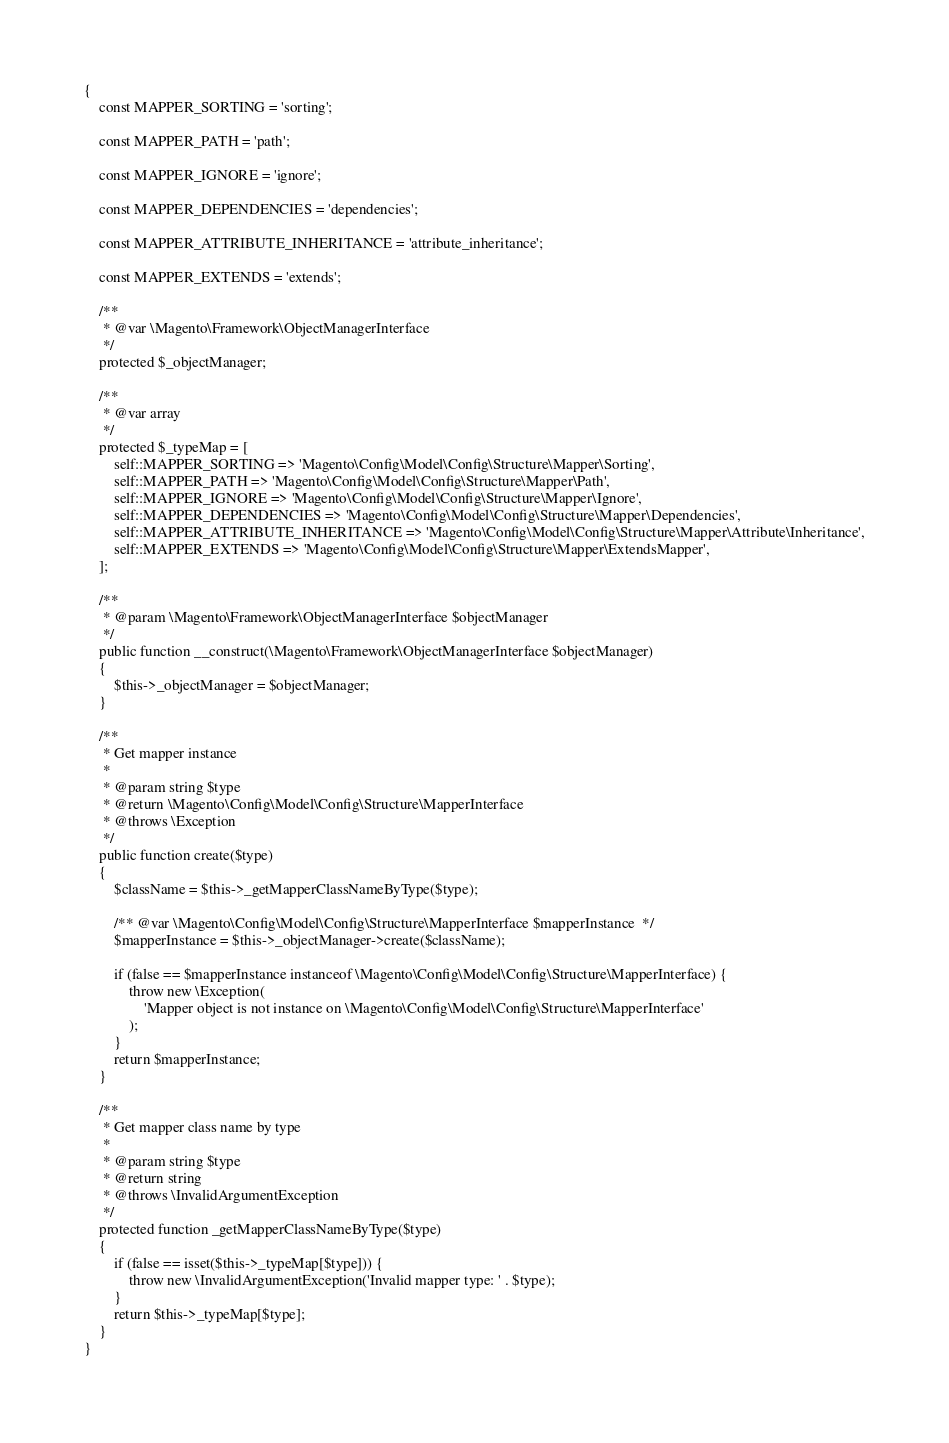Convert code to text. <code><loc_0><loc_0><loc_500><loc_500><_PHP_>{
    const MAPPER_SORTING = 'sorting';

    const MAPPER_PATH = 'path';

    const MAPPER_IGNORE = 'ignore';

    const MAPPER_DEPENDENCIES = 'dependencies';

    const MAPPER_ATTRIBUTE_INHERITANCE = 'attribute_inheritance';

    const MAPPER_EXTENDS = 'extends';

    /**
     * @var \Magento\Framework\ObjectManagerInterface
     */
    protected $_objectManager;

    /**
     * @var array
     */
    protected $_typeMap = [
        self::MAPPER_SORTING => 'Magento\Config\Model\Config\Structure\Mapper\Sorting',
        self::MAPPER_PATH => 'Magento\Config\Model\Config\Structure\Mapper\Path',
        self::MAPPER_IGNORE => 'Magento\Config\Model\Config\Structure\Mapper\Ignore',
        self::MAPPER_DEPENDENCIES => 'Magento\Config\Model\Config\Structure\Mapper\Dependencies',
        self::MAPPER_ATTRIBUTE_INHERITANCE => 'Magento\Config\Model\Config\Structure\Mapper\Attribute\Inheritance',
        self::MAPPER_EXTENDS => 'Magento\Config\Model\Config\Structure\Mapper\ExtendsMapper',
    ];

    /**
     * @param \Magento\Framework\ObjectManagerInterface $objectManager
     */
    public function __construct(\Magento\Framework\ObjectManagerInterface $objectManager)
    {
        $this->_objectManager = $objectManager;
    }

    /**
     * Get mapper instance
     *
     * @param string $type
     * @return \Magento\Config\Model\Config\Structure\MapperInterface
     * @throws \Exception
     */
    public function create($type)
    {
        $className = $this->_getMapperClassNameByType($type);

        /** @var \Magento\Config\Model\Config\Structure\MapperInterface $mapperInstance  */
        $mapperInstance = $this->_objectManager->create($className);

        if (false == $mapperInstance instanceof \Magento\Config\Model\Config\Structure\MapperInterface) {
            throw new \Exception(
                'Mapper object is not instance on \Magento\Config\Model\Config\Structure\MapperInterface'
            );
        }
        return $mapperInstance;
    }

    /**
     * Get mapper class name by type
     *
     * @param string $type
     * @return string
     * @throws \InvalidArgumentException
     */
    protected function _getMapperClassNameByType($type)
    {
        if (false == isset($this->_typeMap[$type])) {
            throw new \InvalidArgumentException('Invalid mapper type: ' . $type);
        }
        return $this->_typeMap[$type];
    }
}
</code> 